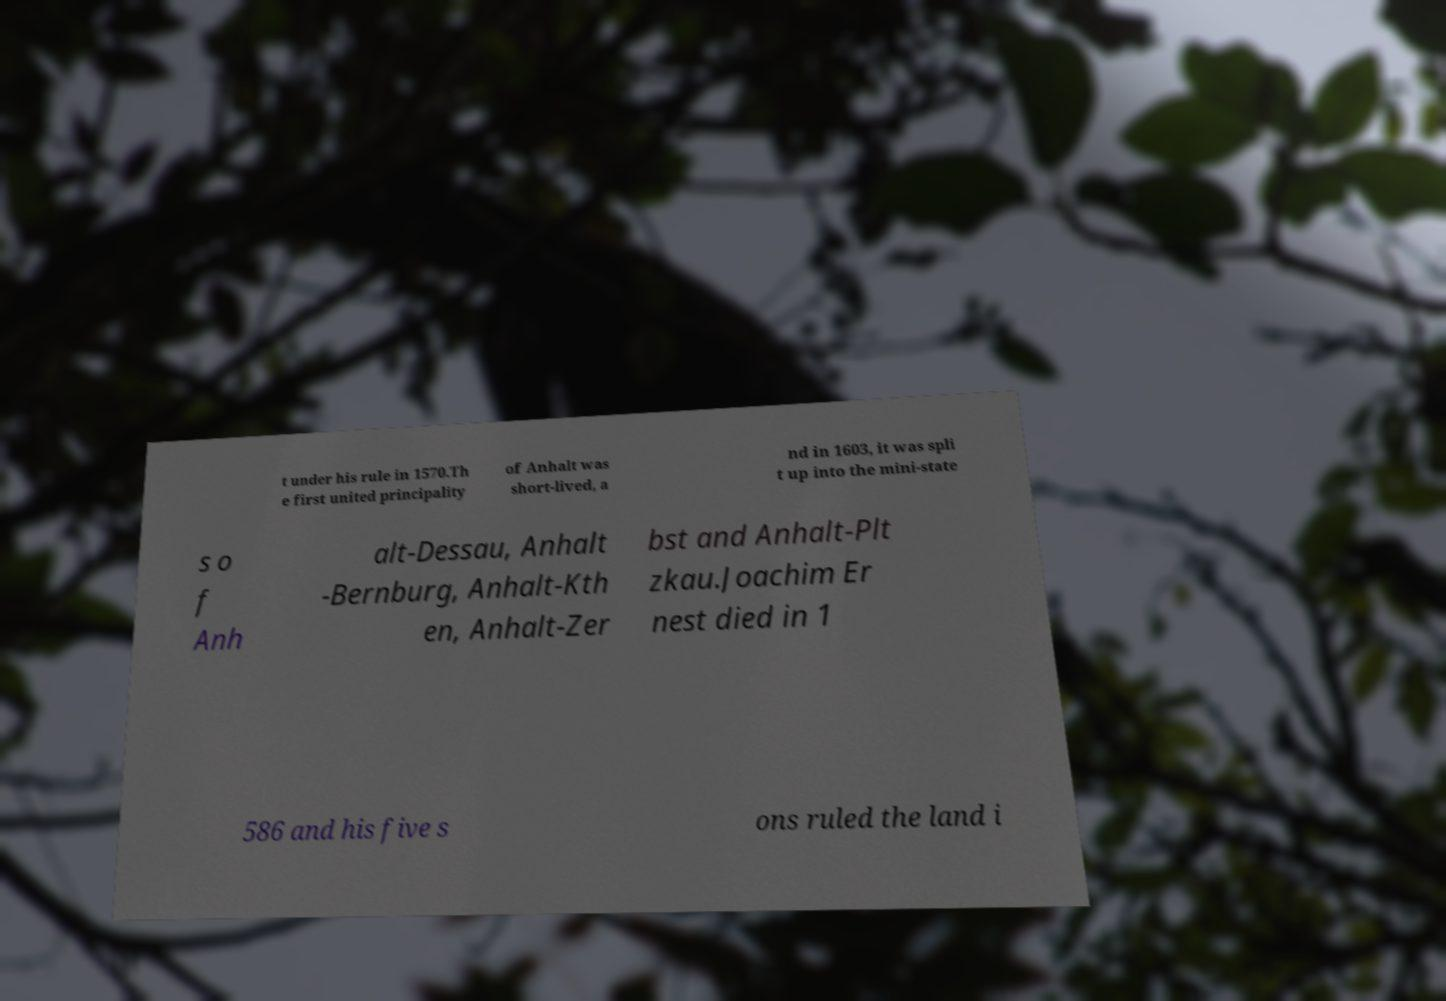Can you read and provide the text displayed in the image?This photo seems to have some interesting text. Can you extract and type it out for me? t under his rule in 1570.Th e first united principality of Anhalt was short-lived, a nd in 1603, it was spli t up into the mini-state s o f Anh alt-Dessau, Anhalt -Bernburg, Anhalt-Kth en, Anhalt-Zer bst and Anhalt-Plt zkau.Joachim Er nest died in 1 586 and his five s ons ruled the land i 